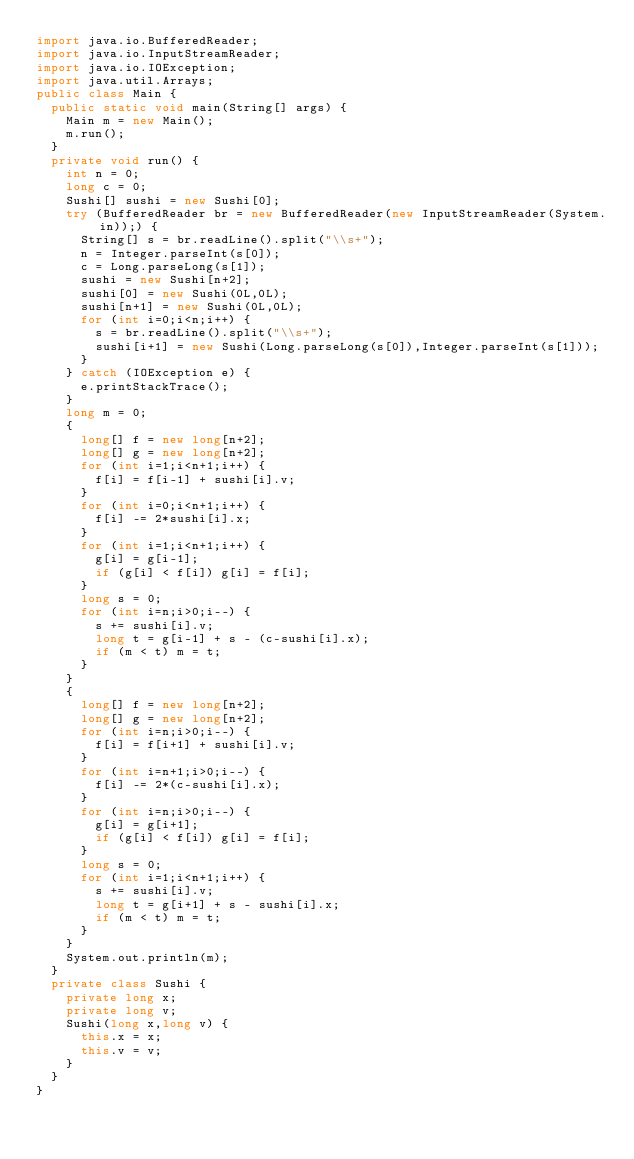Convert code to text. <code><loc_0><loc_0><loc_500><loc_500><_Java_>import java.io.BufferedReader;
import java.io.InputStreamReader;
import java.io.IOException;
import java.util.Arrays;
public class Main {
  public static void main(String[] args) {
    Main m = new Main();
    m.run();
  }
  private void run() {
    int n = 0;
    long c = 0;
    Sushi[] sushi = new Sushi[0];
    try (BufferedReader br = new BufferedReader(new InputStreamReader(System.in));) {
      String[] s = br.readLine().split("\\s+");
      n = Integer.parseInt(s[0]);
      c = Long.parseLong(s[1]);
      sushi = new Sushi[n+2];
      sushi[0] = new Sushi(0L,0L);
      sushi[n+1] = new Sushi(0L,0L);
      for (int i=0;i<n;i++) {
        s = br.readLine().split("\\s+");
        sushi[i+1] = new Sushi(Long.parseLong(s[0]),Integer.parseInt(s[1]));
      }
    } catch (IOException e) {
      e.printStackTrace();
    }
    long m = 0;
    {
      long[] f = new long[n+2];
      long[] g = new long[n+2];
      for (int i=1;i<n+1;i++) {
        f[i] = f[i-1] + sushi[i].v;
      }
      for (int i=0;i<n+1;i++) {
        f[i] -= 2*sushi[i].x;
      }
      for (int i=1;i<n+1;i++) {
        g[i] = g[i-1];
        if (g[i] < f[i]) g[i] = f[i];
      }
      long s = 0;
      for (int i=n;i>0;i--) {
        s += sushi[i].v;
        long t = g[i-1] + s - (c-sushi[i].x);
        if (m < t) m = t;
      }
    }
    {
      long[] f = new long[n+2];
      long[] g = new long[n+2];
      for (int i=n;i>0;i--) {
        f[i] = f[i+1] + sushi[i].v;
      }
      for (int i=n+1;i>0;i--) {
        f[i] -= 2*(c-sushi[i].x);
      }
      for (int i=n;i>0;i--) {
        g[i] = g[i+1];
        if (g[i] < f[i]) g[i] = f[i];
      }
      long s = 0;
      for (int i=1;i<n+1;i++) {
        s += sushi[i].v;
        long t = g[i+1] + s - sushi[i].x;
        if (m < t) m = t;
      }
    }
    System.out.println(m);
  }
  private class Sushi {
    private long x;
    private long v;
    Sushi(long x,long v) {
      this.x = x;
      this.v = v;
    }
  }
}</code> 